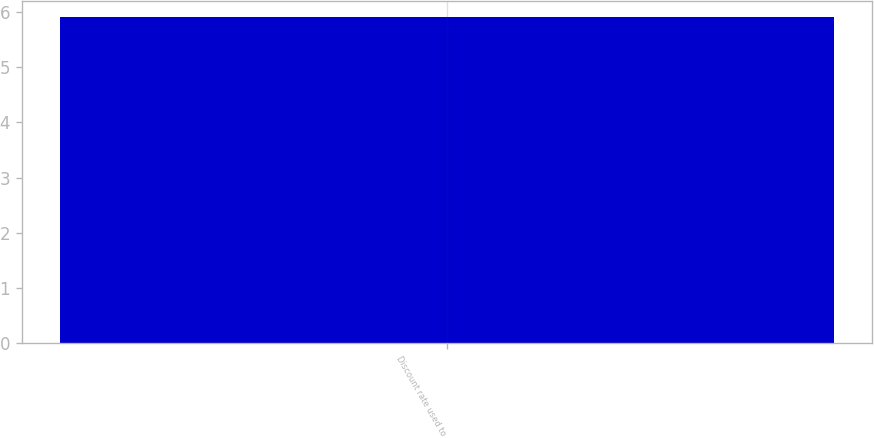Convert chart. <chart><loc_0><loc_0><loc_500><loc_500><bar_chart><fcel>Discount rate used to<nl><fcel>5.91<nl></chart> 